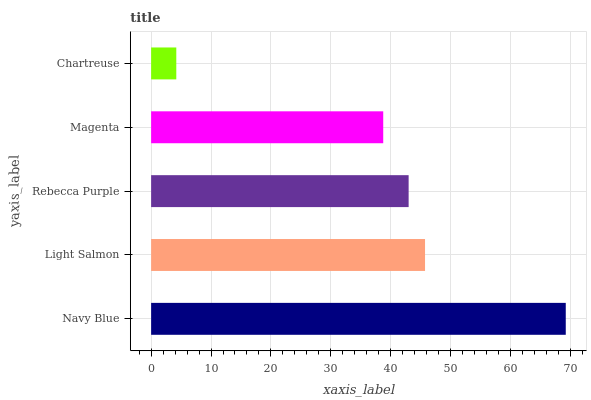Is Chartreuse the minimum?
Answer yes or no. Yes. Is Navy Blue the maximum?
Answer yes or no. Yes. Is Light Salmon the minimum?
Answer yes or no. No. Is Light Salmon the maximum?
Answer yes or no. No. Is Navy Blue greater than Light Salmon?
Answer yes or no. Yes. Is Light Salmon less than Navy Blue?
Answer yes or no. Yes. Is Light Salmon greater than Navy Blue?
Answer yes or no. No. Is Navy Blue less than Light Salmon?
Answer yes or no. No. Is Rebecca Purple the high median?
Answer yes or no. Yes. Is Rebecca Purple the low median?
Answer yes or no. Yes. Is Chartreuse the high median?
Answer yes or no. No. Is Light Salmon the low median?
Answer yes or no. No. 